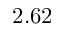<formula> <loc_0><loc_0><loc_500><loc_500>2 . 6 2</formula> 